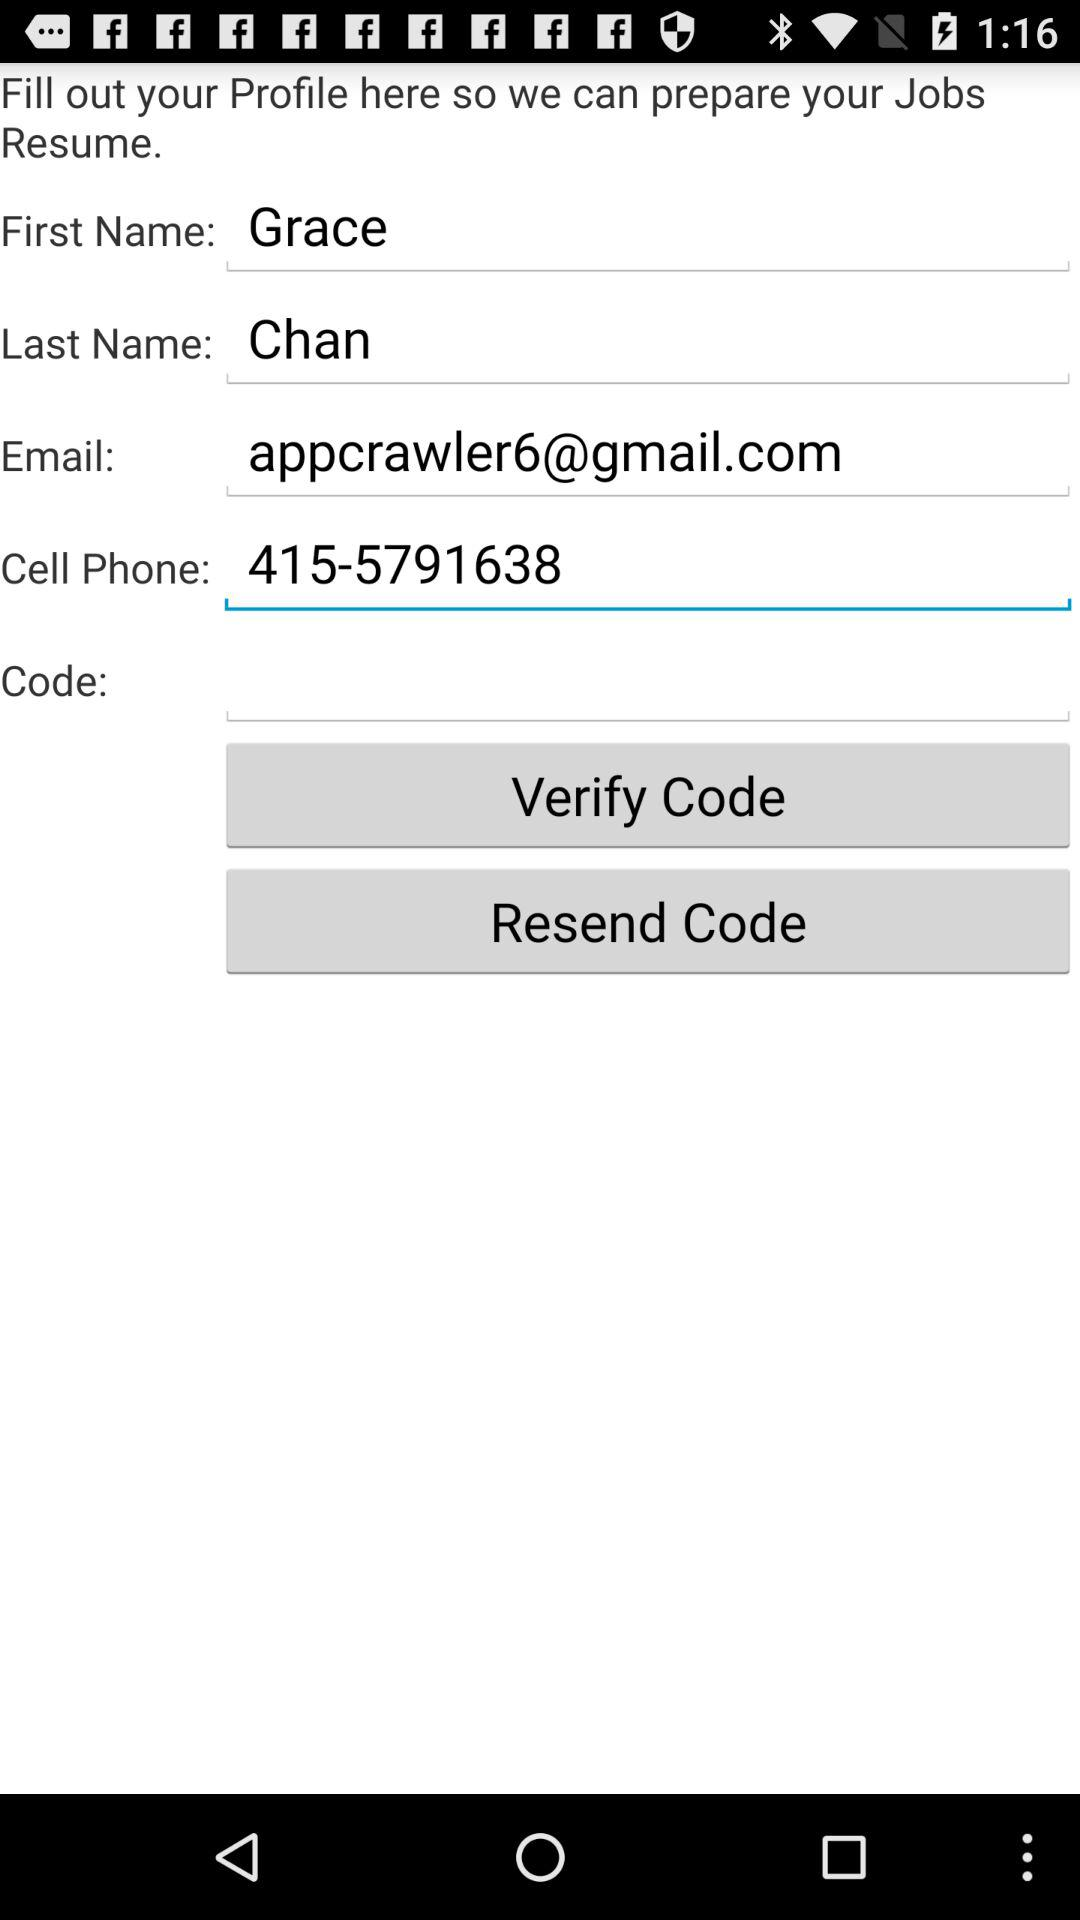What's the first name? The first name is Grace. 